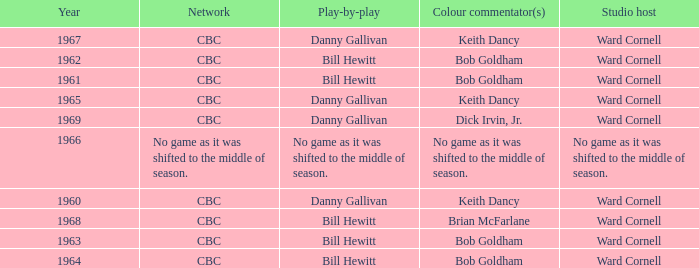Who did the play-by-play on the CBC network before 1961? Danny Gallivan. 